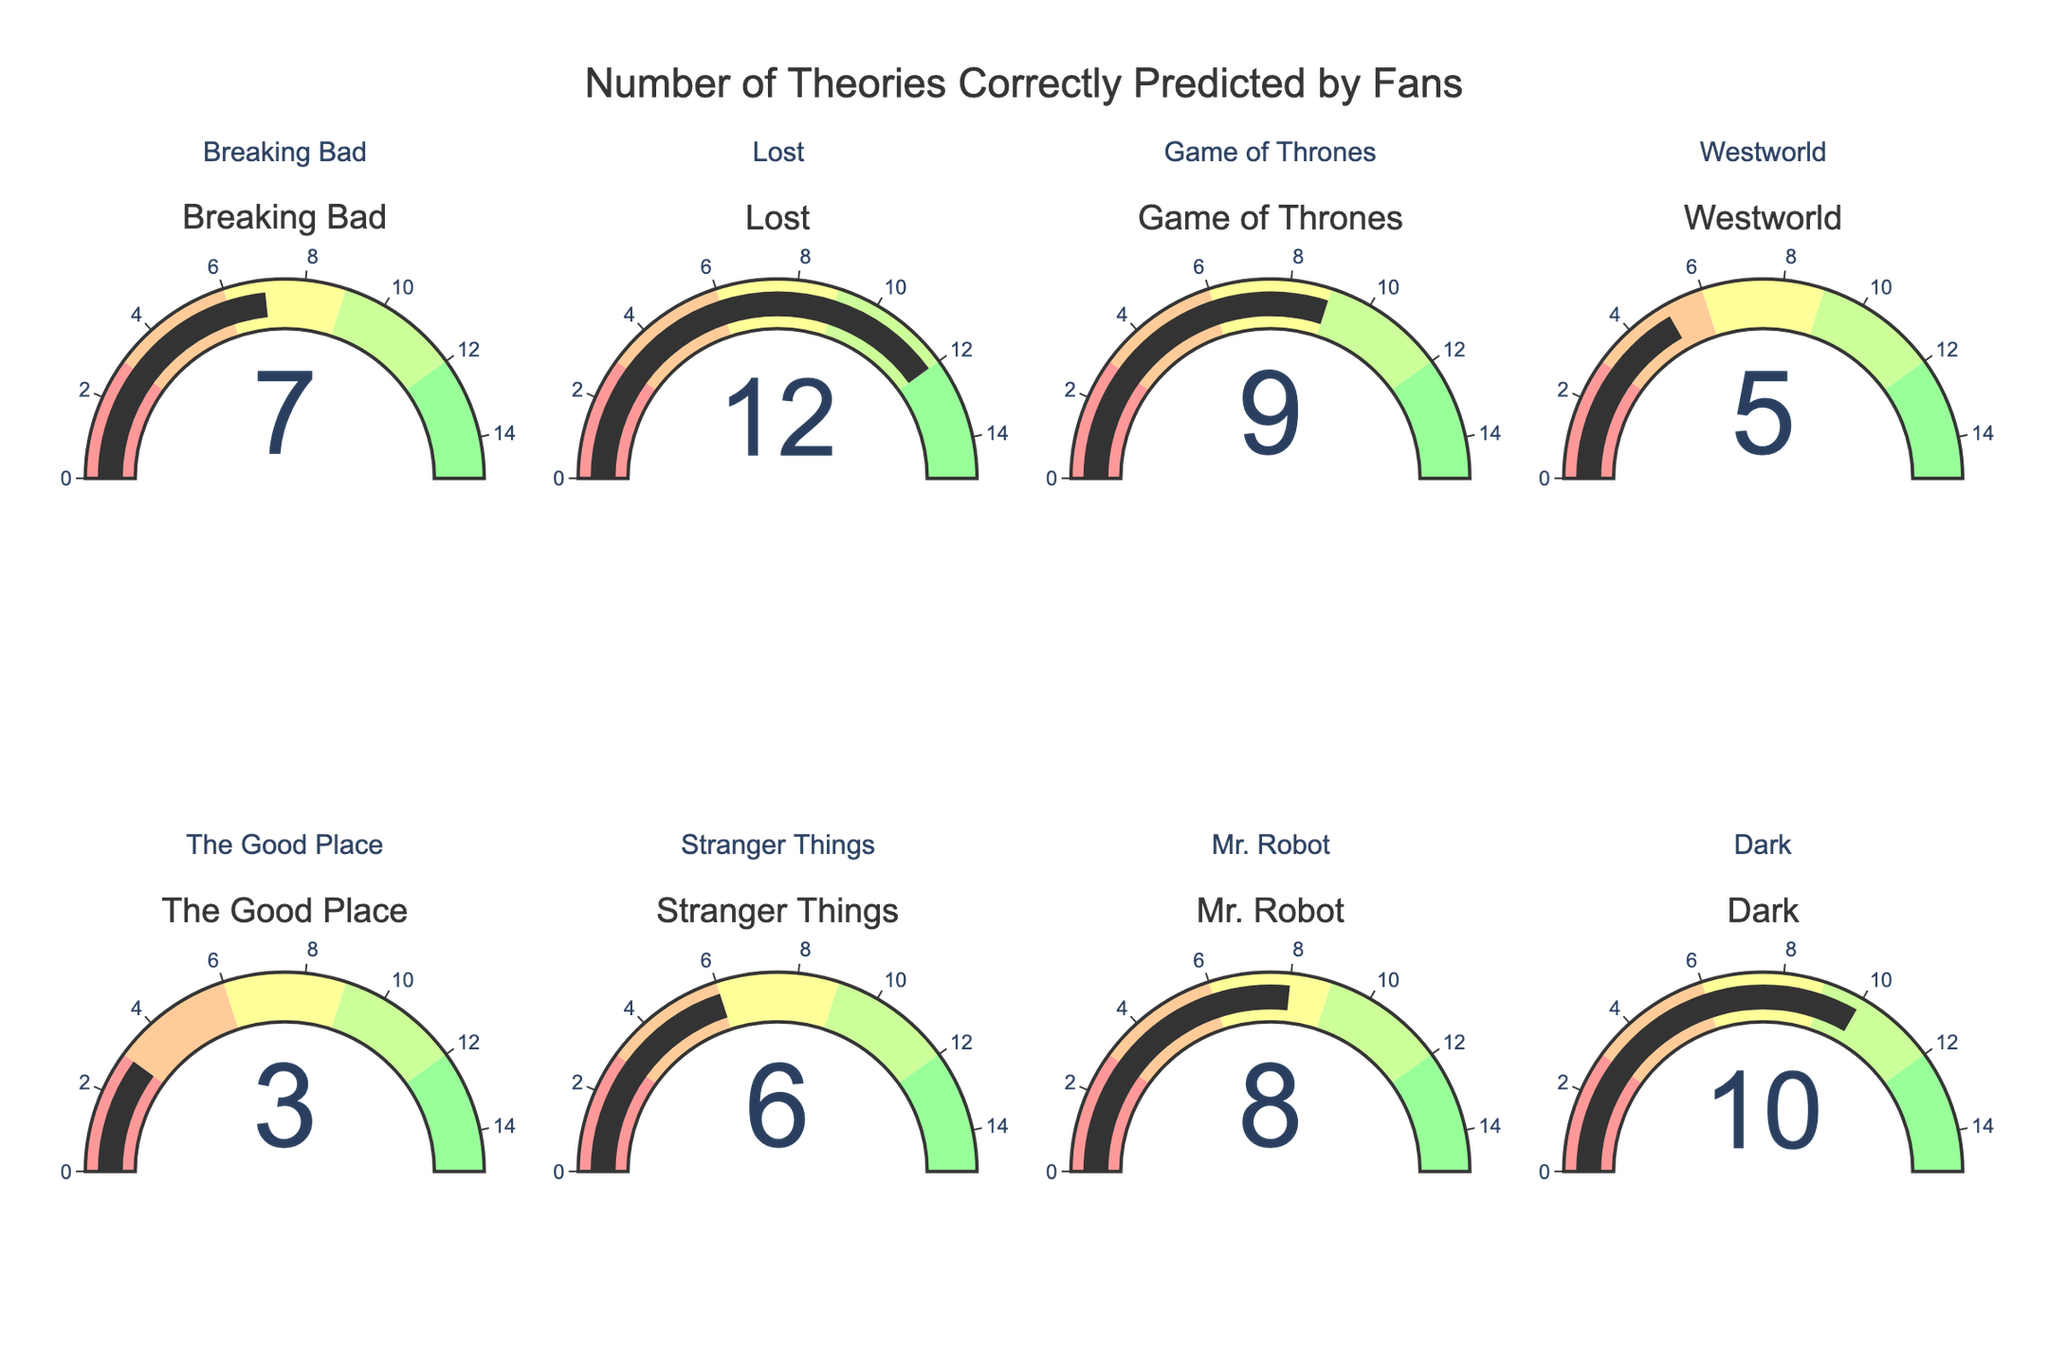What is the title of the figure? The title is usually displayed at the top of the figure. In the given figure, the title says "Number of Theories Correctly Predicted by Fans".
Answer: Number of Theories Correctly Predicted by Fans How many television series are represented in the gauge charts? There are gauges for each television series. Counting each title, there are a total of 8 series represented.
Answer: 8 Which television series has the highest number of correct predictions by fans? By looking at the value displayed on each gauge, "Lost" has the highest value of 12.
Answer: Lost What is the total number of correct predictions for "Breaking Bad" and "Mr. Robot"? The number for Breaking Bad is 7 and for Mr. Robot is 8. Adding these gives 7 + 8 = 15.
Answer: 15 How many series have more than 6 correct predictions? Breaking Bad (7), Game of Thrones (9), Mr. Robot (8), Dark (10), and Lost (12) all have more than 6 correct predictions. Counting these, there are 5 series.
Answer: 5 What is the range of the gauge axis? The range is shown on the axis of the gauges. It goes from 0 to 15.
Answer: 0 to 15 Which series has the lowest number of correct predictions? Looking at the values displayed, "The Good Place" has the lowest number with a value of 3.
Answer: The Good Place What is the average number of correct predictions across all the series? Sum the values: 7 + 12 + 9 + 5 + 3 + 6 + 8 + 10 = 60; Divide by the number of series, which is 8. The average is 60 / 8 = 7.5.
Answer: 7.5 Are there any series that have exactly 6 correct predictions? Yes, "Stranger Things" has exactly 6 correct predictions.
Answer: Stranger Things Which series have correct predictions in the range [9, 12)? The series in this range are "Game of Thrones" (9) and "Dark" (10), as these values fall within the inclusive lower bound and exclusive upper bound [9, 12).
Answer: Game of Thrones, Dark 